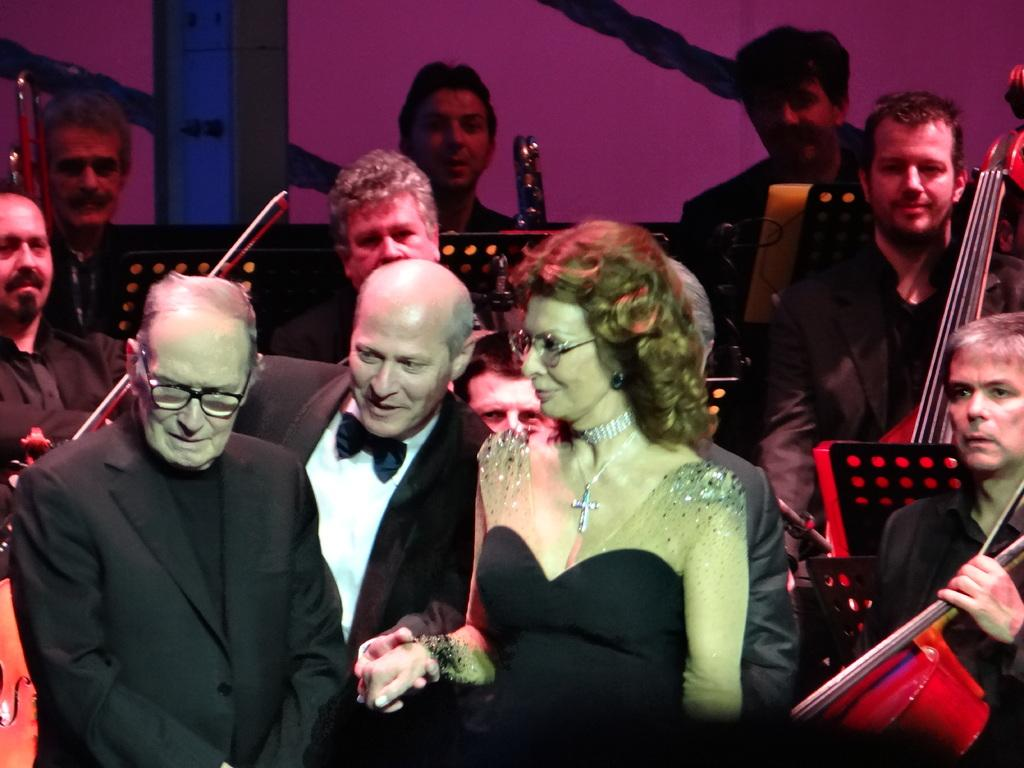What is happening in the image? There is a group of people in the image, and they are holding musical instruments. Can you describe the people in the image? Yes, there is a woman standing in the middle of the group. How many apples are being held by the people in the image? There are no apples present in the image; the people are holding musical instruments. 